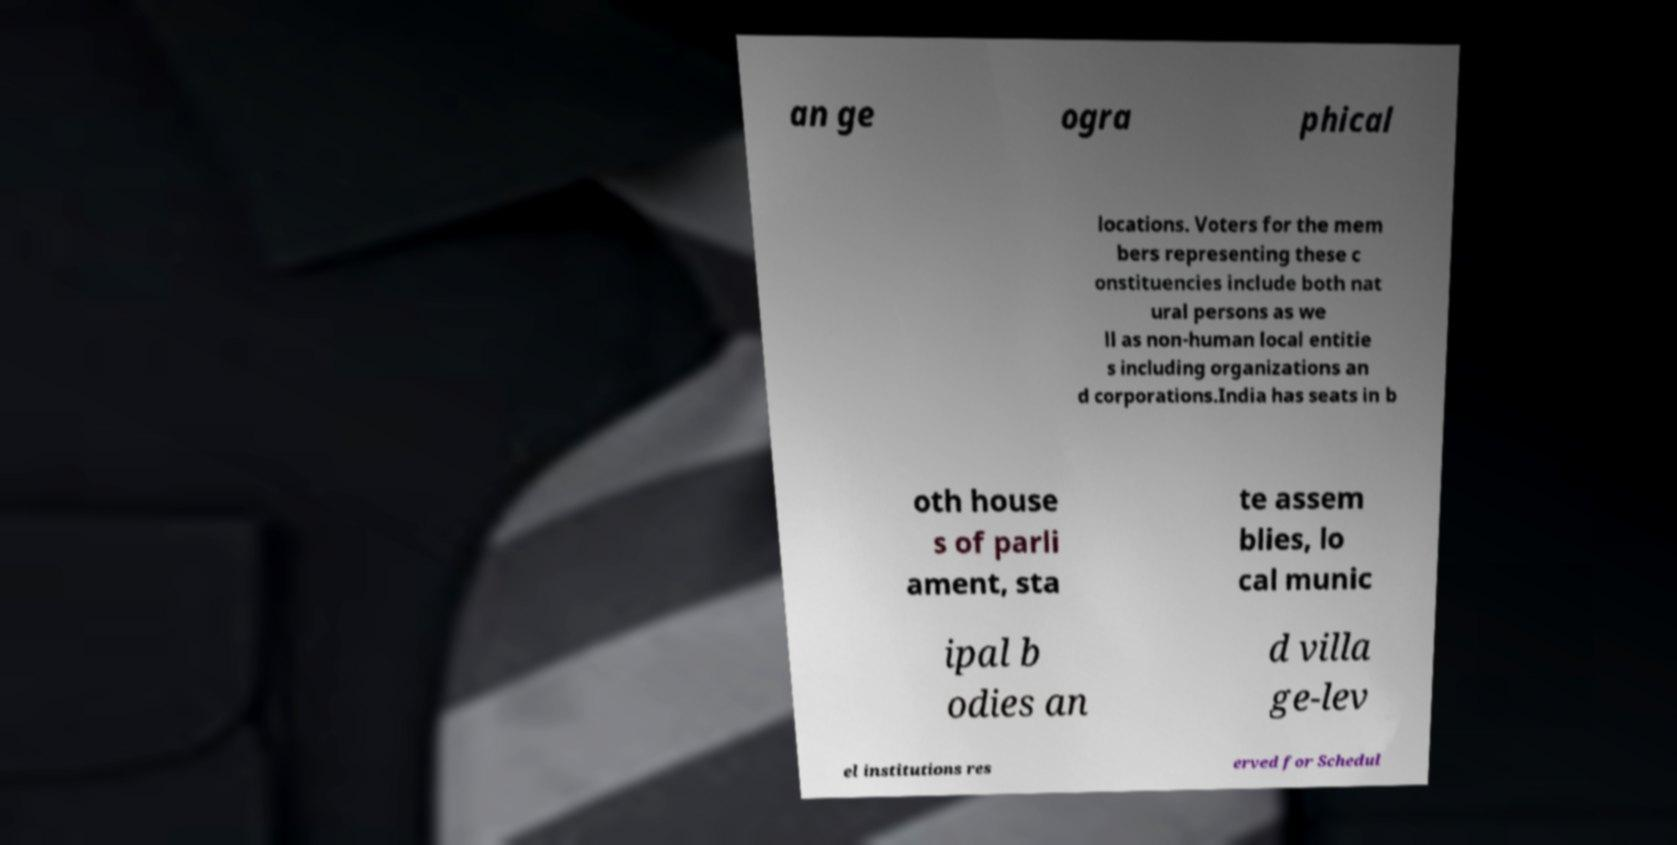Could you assist in decoding the text presented in this image and type it out clearly? an ge ogra phical locations. Voters for the mem bers representing these c onstituencies include both nat ural persons as we ll as non-human local entitie s including organizations an d corporations.India has seats in b oth house s of parli ament, sta te assem blies, lo cal munic ipal b odies an d villa ge-lev el institutions res erved for Schedul 